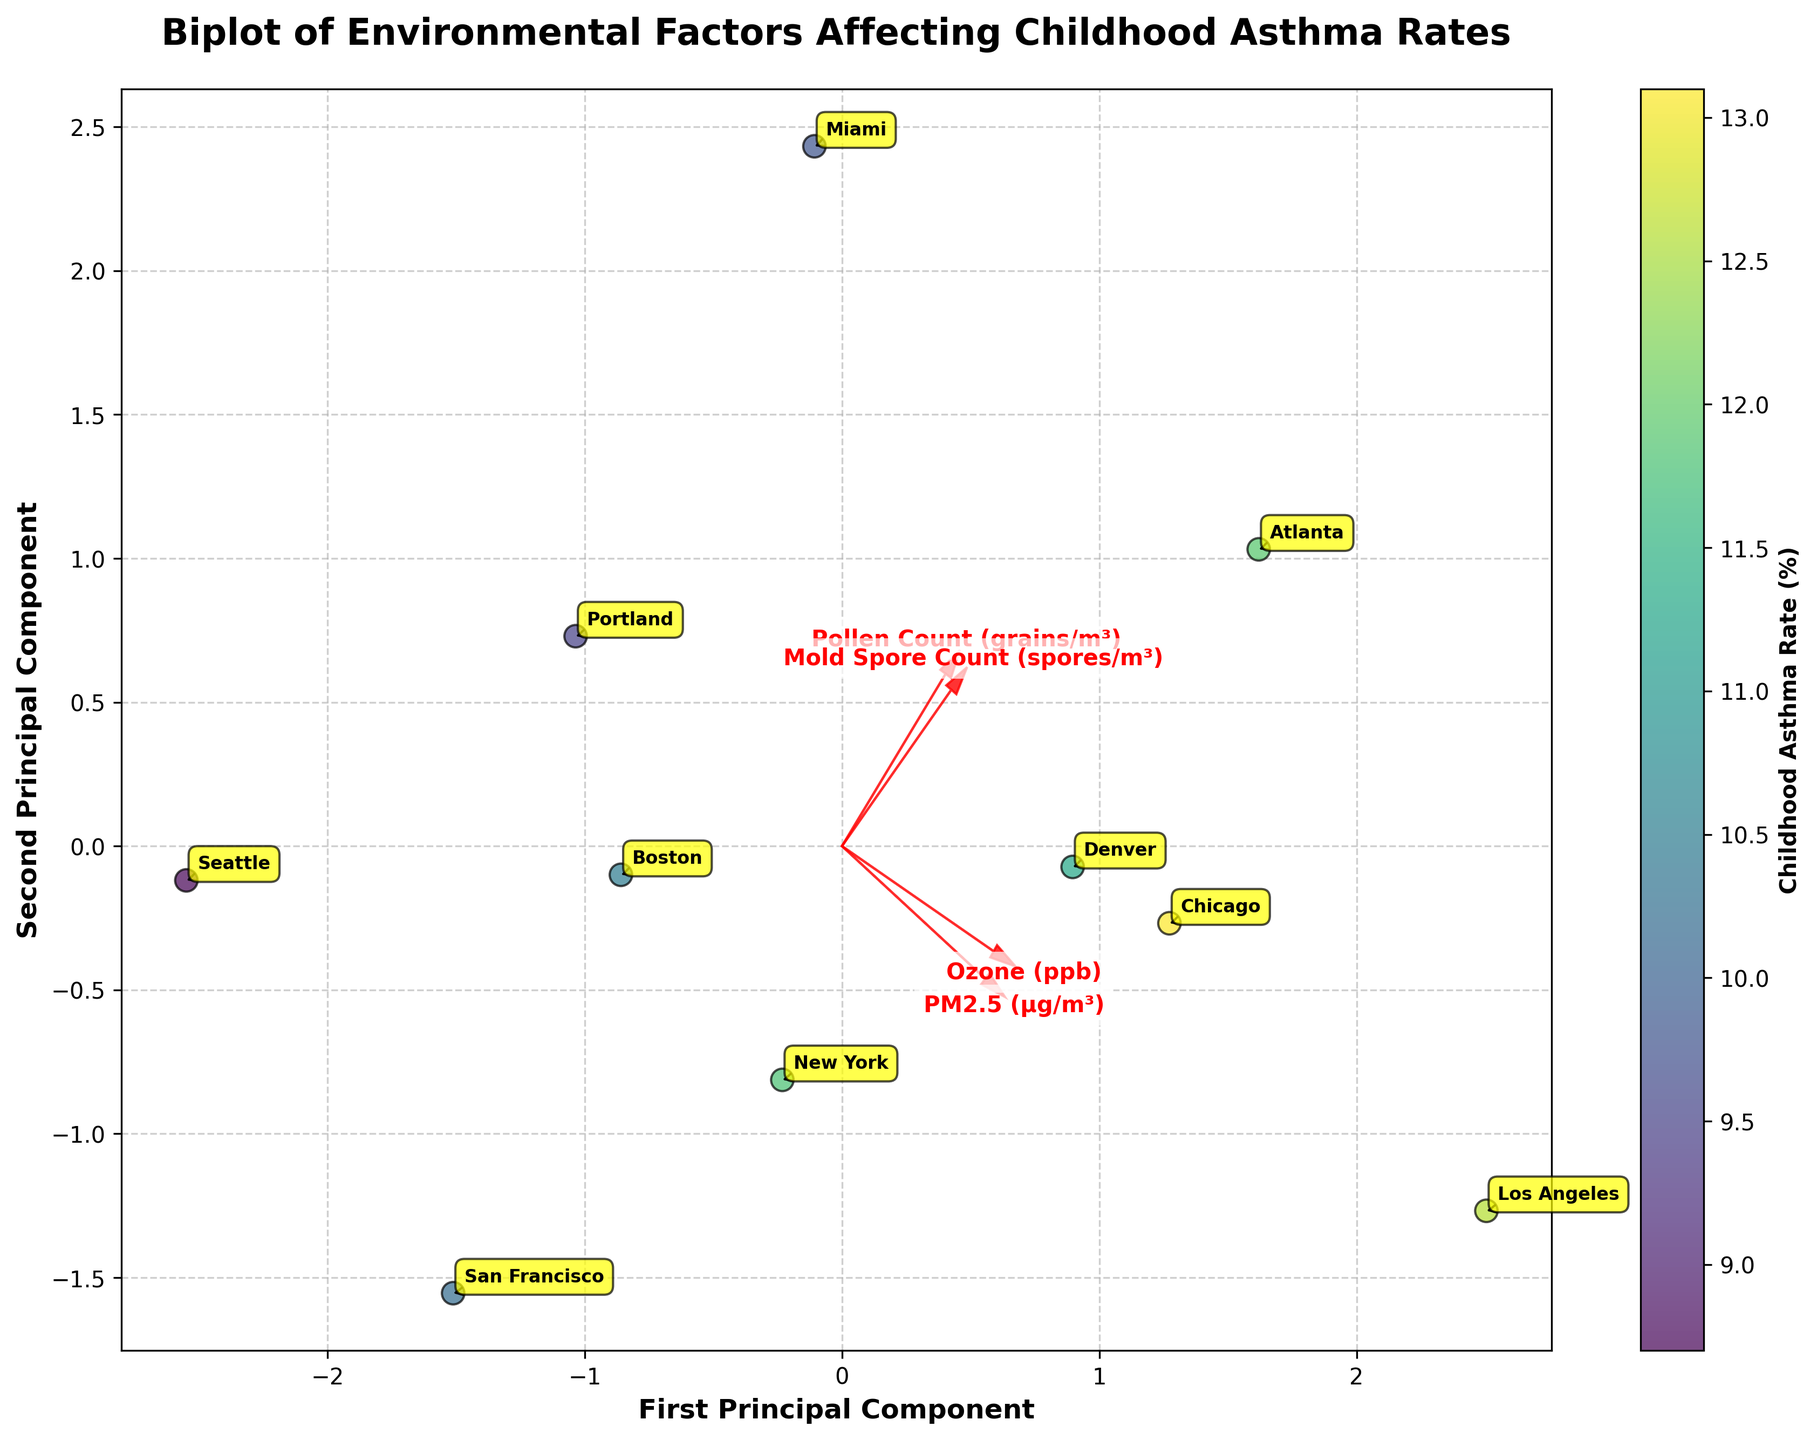What is the title of the biplot? The title is typically placed at the top of the plot. It provides an overview of what the plot is about.
Answer: Biplot of Environmental Factors Affecting Childhood Asthma Rates How many cities are represented in the biplot? By counting the number of data points or annotations for city names, we can determine the number of cities.
Answer: 10 Which city has the highest childhood asthma rate as represented by the color mapping? By examining the color scale and identifying the data point with the darkest color, we can determine the city with the highest asthma rate.
Answer: Chicago Which environmental factor is most aligned with the first principal component (x-axis)? By looking at the arrows representing environmental factors, we can determine which arrow is most closely aligned with the x-axis (horizontal direction).
Answer: PM2.5 (µg/m³) How is the magnitude of 'Mold Spore Count' represented in the plot? The magnitude of 'Mold Spore Count' can be inferred from the length of its arrow; longer arrows represent higher magnitudes.
Answer: It has a moderate length arrow Compare the asthma rates of Los Angeles and Miami. Which city has a higher rate and by how much? Locate both cities' data points and refer to the color gradient or annotated values. Subtract Miami's rate from Los Angeles'.
Answer: Los Angeles has a higher rate by 2.8% Which environmental factor appears to have the least influence in the second principal component (y-axis)? Examine the placement and alignment of feature vectors to the y-axis. The less aligned the vector, the less its influence.
Answer: Ozone (ppb) What does the color gradient on the plot indicate? The color gradient runs from lighter to darker shades, representing different ranges of asthma rates. It helps in easily recognizing high and low rates.
Answer: Childhood Asthma Rate (%) Are higher pollen counts associated with higher or lower childhood asthma rates? Compare the direction of the 'Pollen Count' vector with the positions and colors of the data points that align with high asthma rates.
Answer: Higher pollen counts are associated with higher childhood asthma rates What can you infer about the relationship between 'Ozone (ppb)' and childhood asthma rates based on their vector direction? Analyze the direction of the 'Ozone (ppb)' vector and its alignment with data points representing different asthma rates.
Answer: Ozone (ppb) appears weakly associated with asthma rates as its vector is not strongly aligned with the high-rate data points 